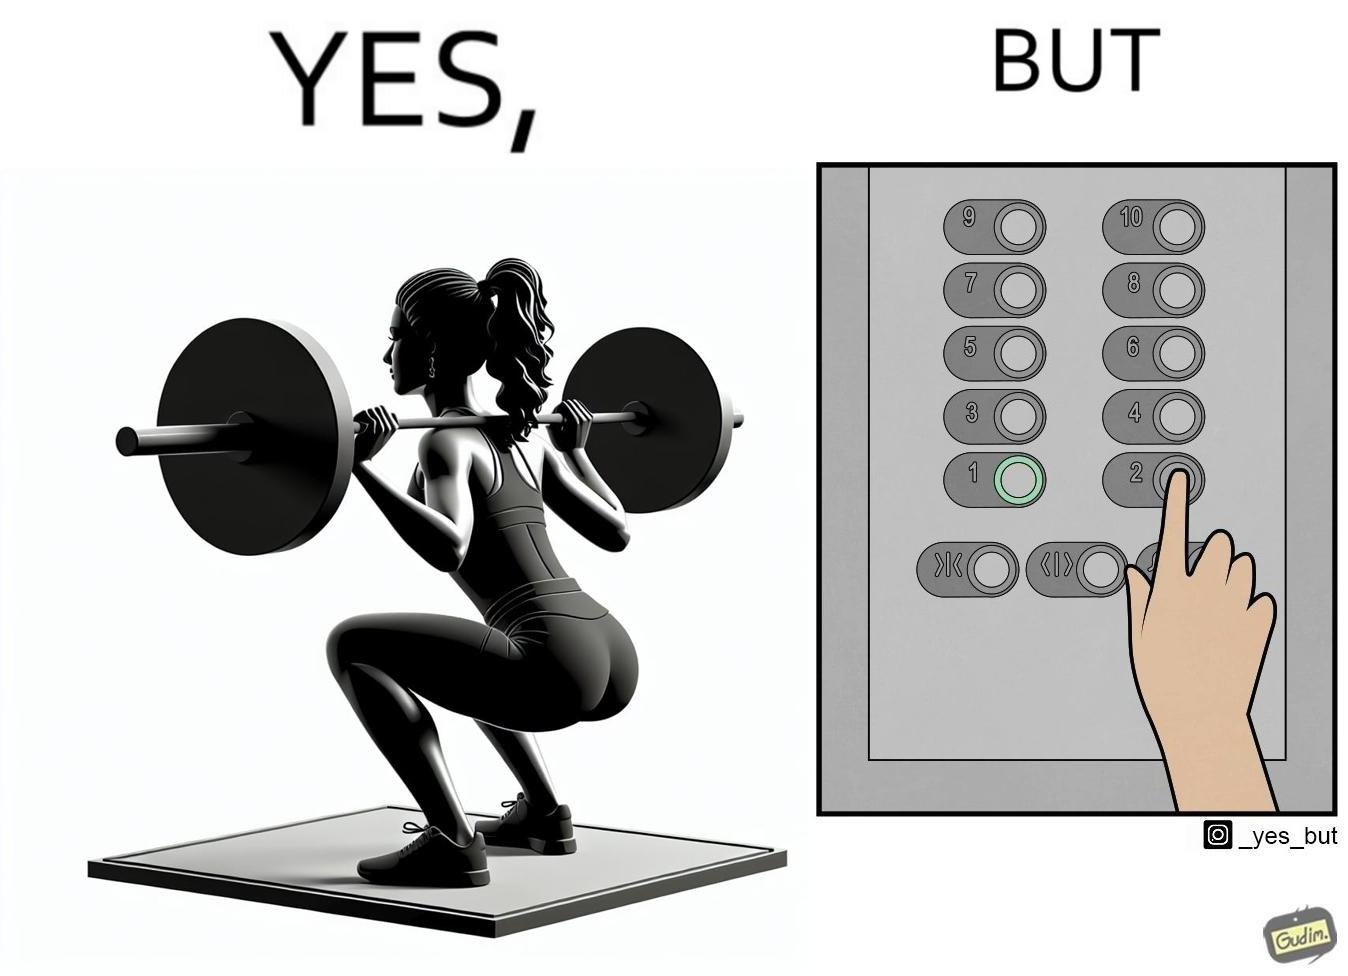Describe the satirical element in this image. The image is satirical because it shows that while people do various kinds of exercises and go to gym to stay fit, they avoid doing simplest of physical tasks like using stairs instead of elevators to get to even the first or the second floor of a building. 